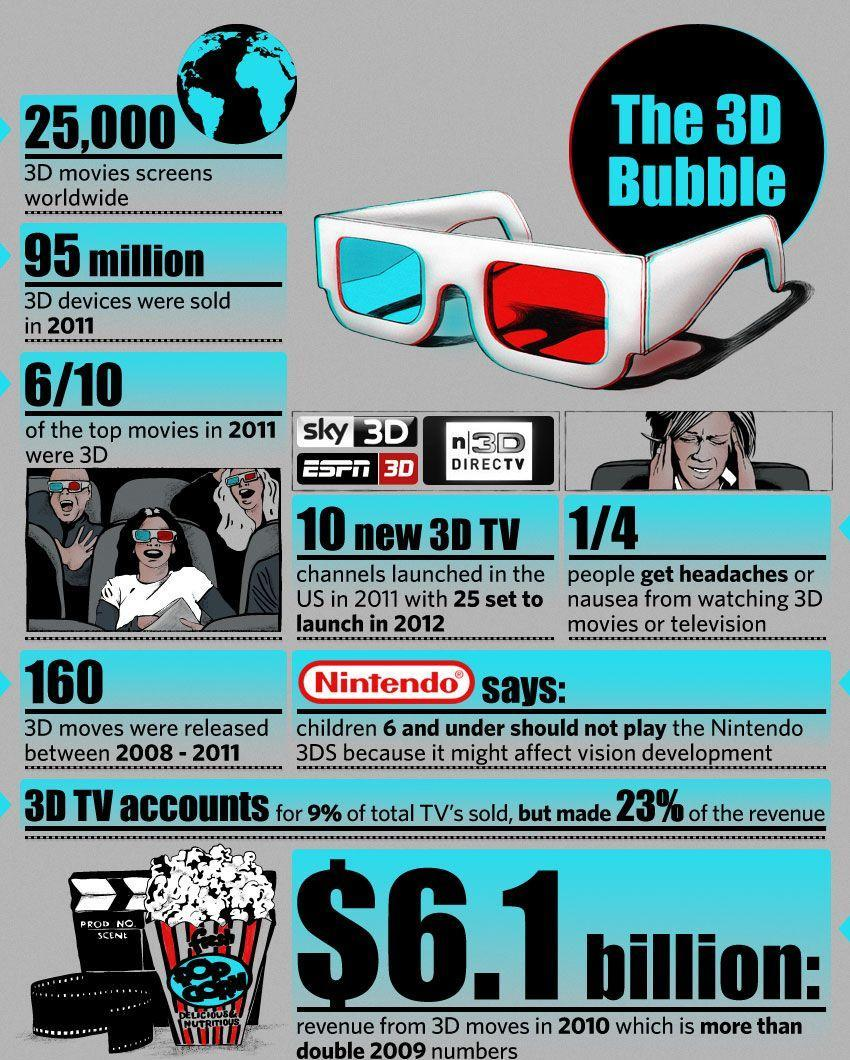How many top movies launched were 3D out of 10 in 2011?
Answer the question with a short phrase. 6 What is the number of 3D devices sold in 2011? 95 million What is the revenue received form 3D movies in 2010? $6.1 billion What is the percentage of revenue made by 3D TV accounts? 23% What is the number of 3D movies release between 2008 - 2011? 160 What is the number of 3D movies screens available worldwide? 25,000 How many new 3D TV channels were launched in the US in 2011? 10 